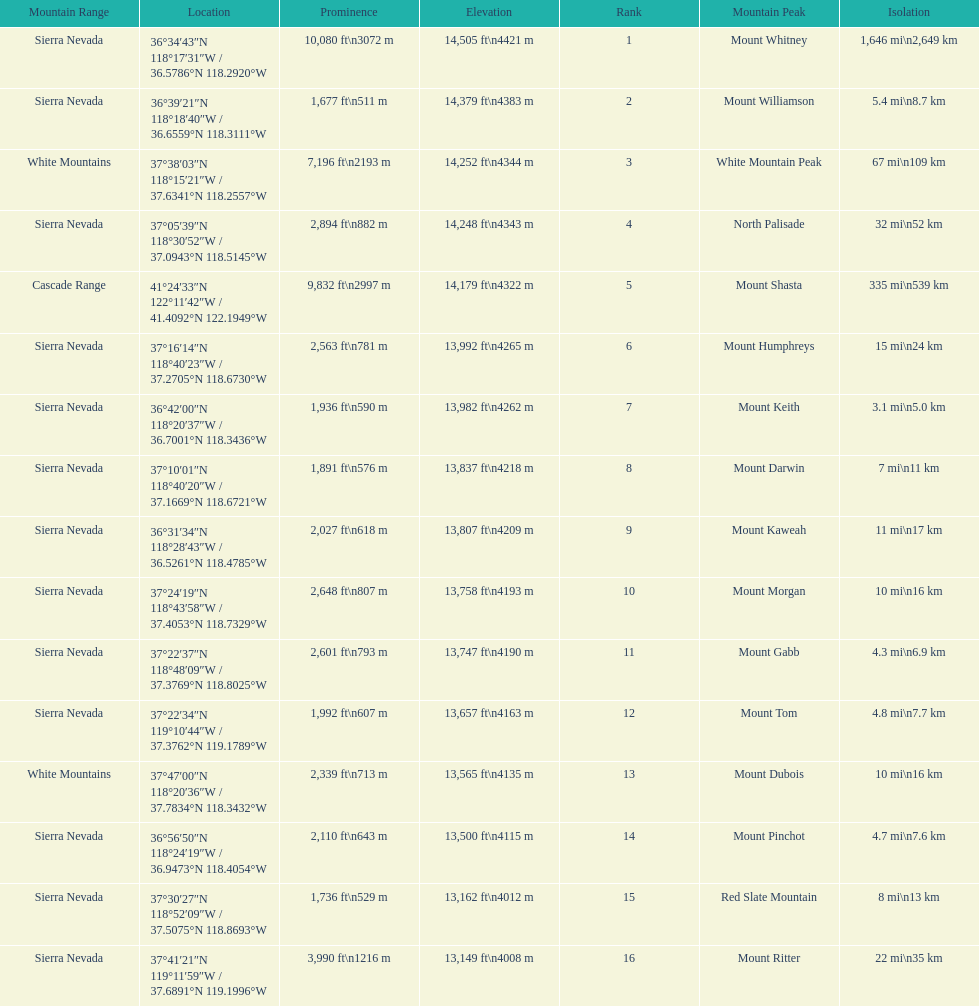What are all of the peaks? Mount Whitney, Mount Williamson, White Mountain Peak, North Palisade, Mount Shasta, Mount Humphreys, Mount Keith, Mount Darwin, Mount Kaweah, Mount Morgan, Mount Gabb, Mount Tom, Mount Dubois, Mount Pinchot, Red Slate Mountain, Mount Ritter. Where are they located? Sierra Nevada, Sierra Nevada, White Mountains, Sierra Nevada, Cascade Range, Sierra Nevada, Sierra Nevada, Sierra Nevada, Sierra Nevada, Sierra Nevada, Sierra Nevada, Sierra Nevada, White Mountains, Sierra Nevada, Sierra Nevada, Sierra Nevada. How tall are they? 14,505 ft\n4421 m, 14,379 ft\n4383 m, 14,252 ft\n4344 m, 14,248 ft\n4343 m, 14,179 ft\n4322 m, 13,992 ft\n4265 m, 13,982 ft\n4262 m, 13,837 ft\n4218 m, 13,807 ft\n4209 m, 13,758 ft\n4193 m, 13,747 ft\n4190 m, 13,657 ft\n4163 m, 13,565 ft\n4135 m, 13,500 ft\n4115 m, 13,162 ft\n4012 m, 13,149 ft\n4008 m. What about just the peaks in the sierra nevadas? 14,505 ft\n4421 m, 14,379 ft\n4383 m, 14,248 ft\n4343 m, 13,992 ft\n4265 m, 13,982 ft\n4262 m, 13,837 ft\n4218 m, 13,807 ft\n4209 m, 13,758 ft\n4193 m, 13,747 ft\n4190 m, 13,657 ft\n4163 m, 13,500 ft\n4115 m, 13,162 ft\n4012 m, 13,149 ft\n4008 m. And of those, which is the tallest? Mount Whitney. 